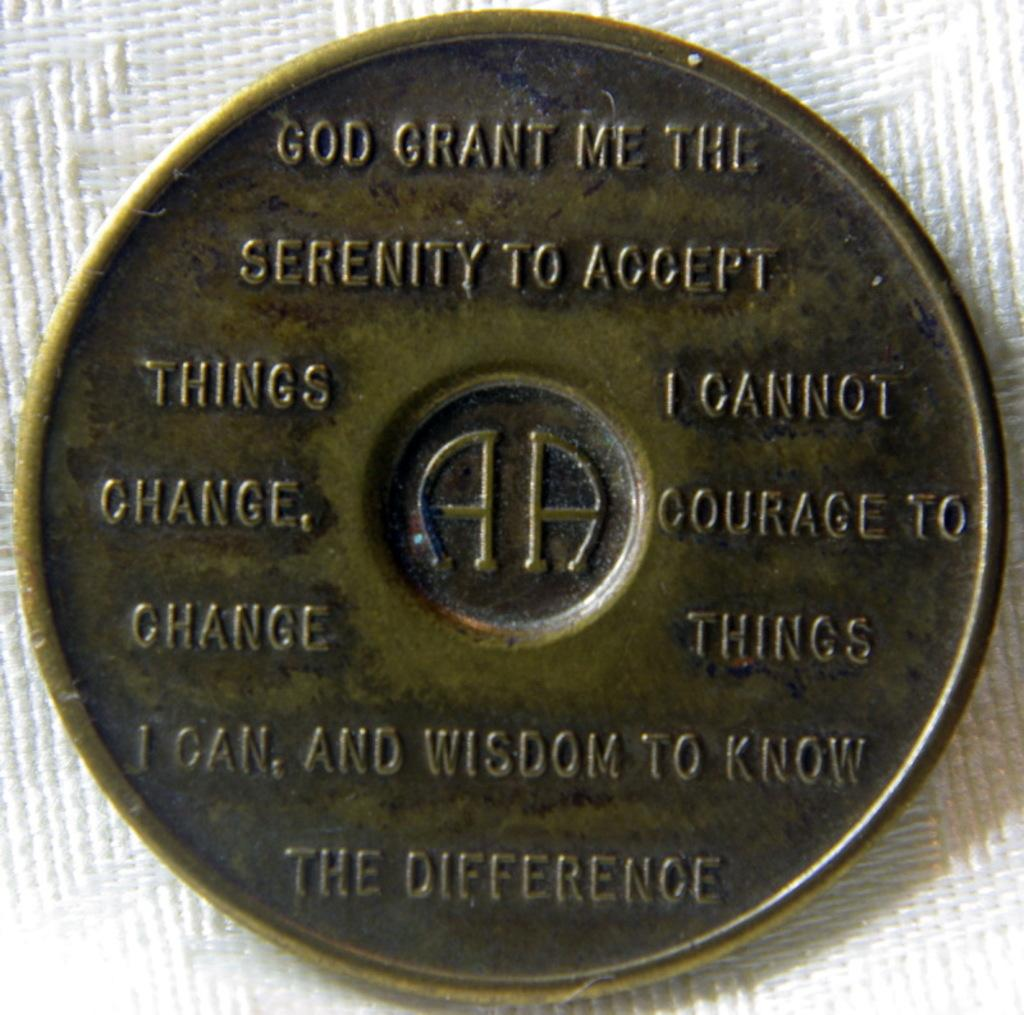<image>
Describe the image concisely. A commemorative Alcoholics Anonymous coin with their motto printed on it. 